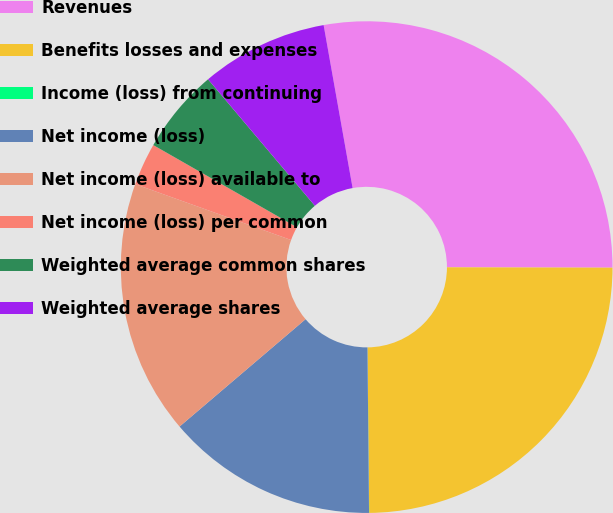<chart> <loc_0><loc_0><loc_500><loc_500><pie_chart><fcel>Revenues<fcel>Benefits losses and expenses<fcel>Income (loss) from continuing<fcel>Net income (loss)<fcel>Net income (loss) available to<fcel>Net income (loss) per common<fcel>Weighted average common shares<fcel>Weighted average shares<nl><fcel>27.84%<fcel>24.8%<fcel>0.01%<fcel>13.92%<fcel>16.71%<fcel>2.79%<fcel>5.57%<fcel>8.36%<nl></chart> 